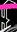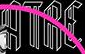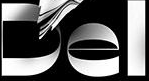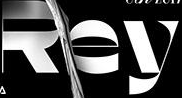What text appears in these images from left to right, separated by a semicolon? #; ATRE; Del; Rey 